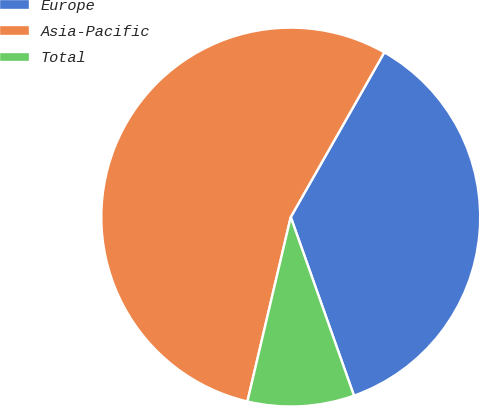<chart> <loc_0><loc_0><loc_500><loc_500><pie_chart><fcel>Europe<fcel>Asia-Pacific<fcel>Total<nl><fcel>36.36%<fcel>54.55%<fcel>9.09%<nl></chart> 